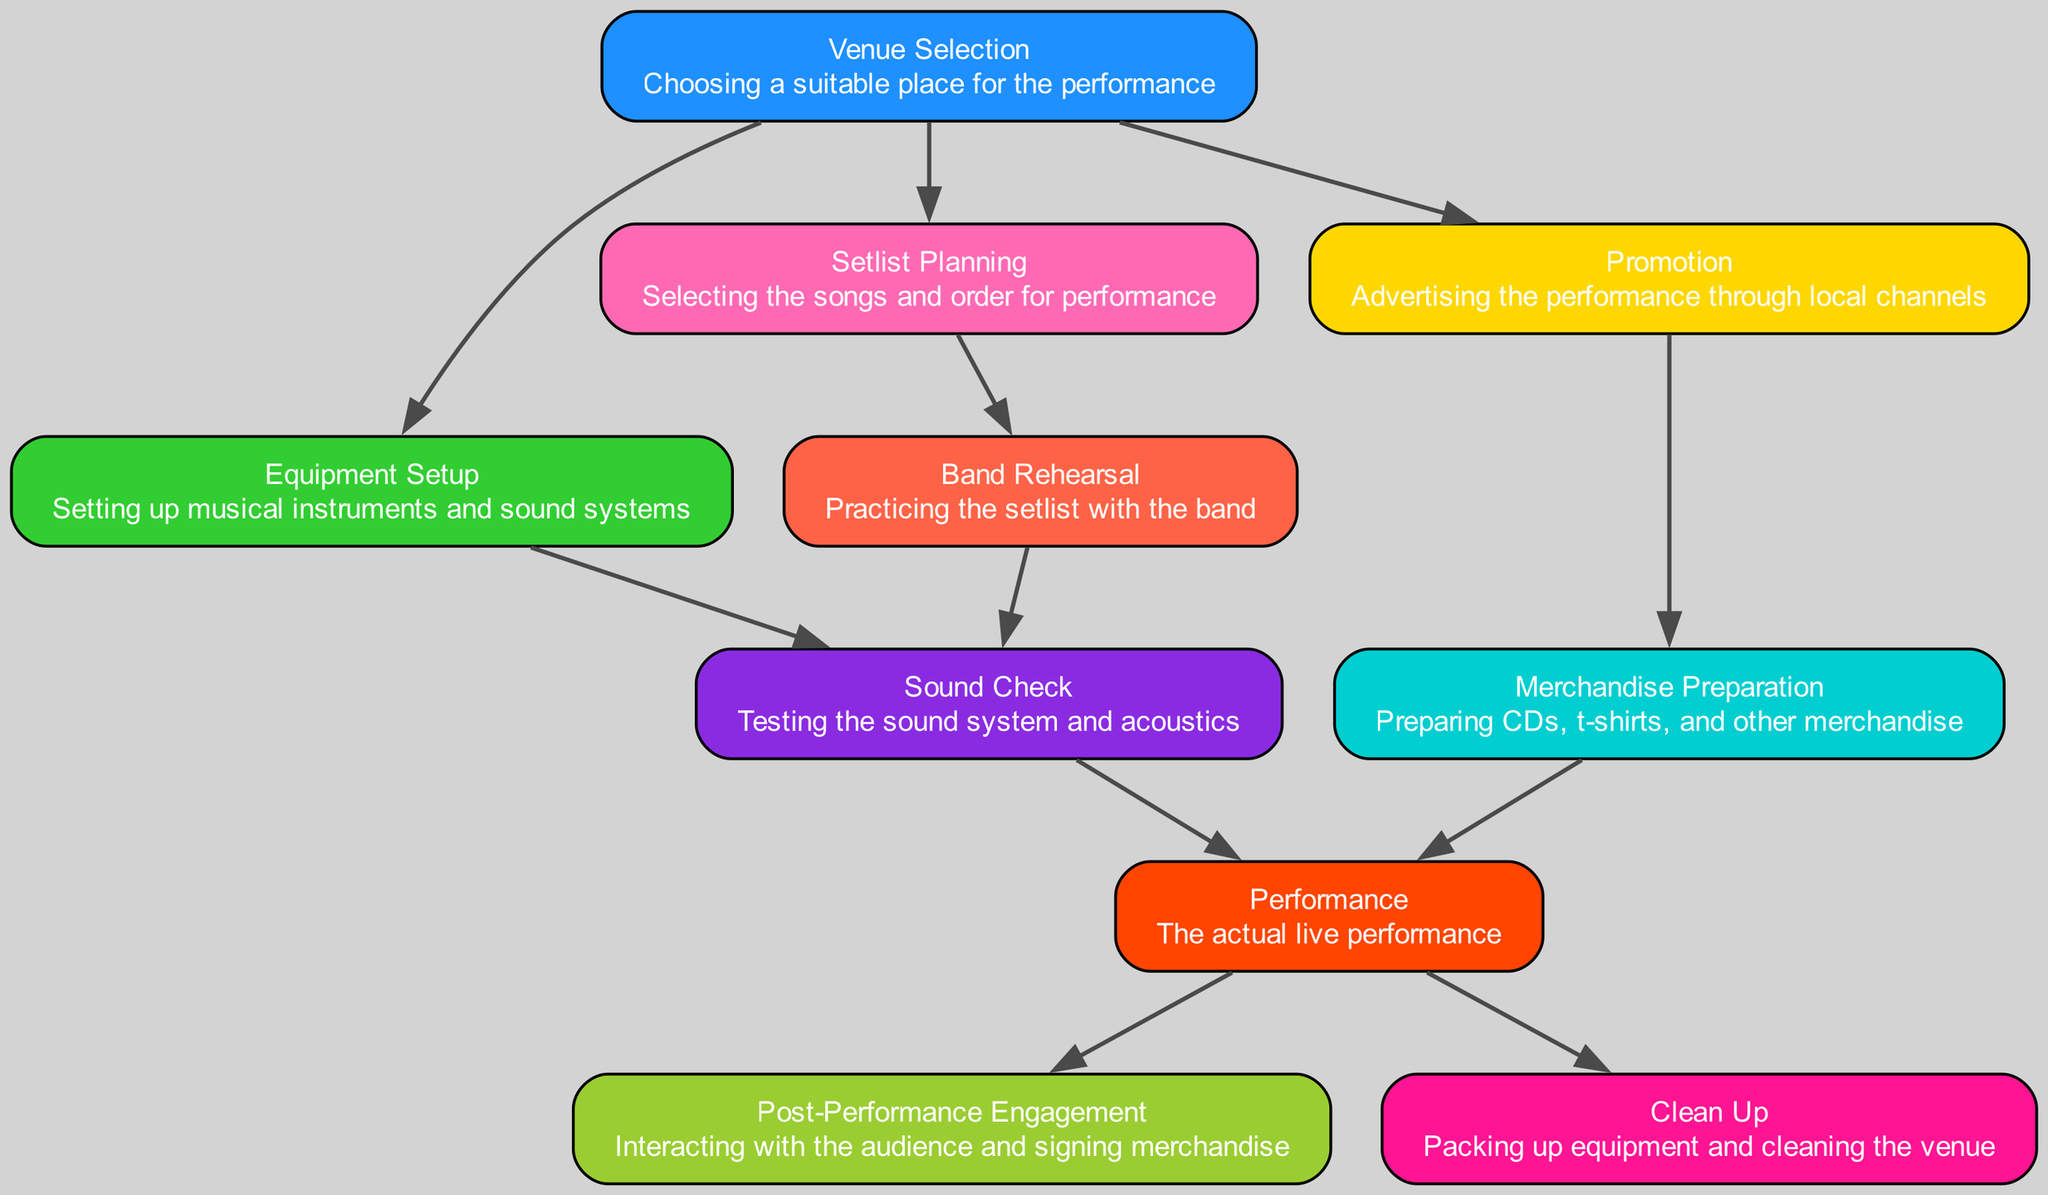What is the first step in organizing a weekend performance? The first step is 'Venue Selection,' which is depicted as the foundational element in the diagram without any dependencies. It's the starting point for any performance organization activities.
Answer: Venue Selection How many total nodes are present in the diagram? By counting the elements listed in the data, there are ten entities shown in the diagram, which represent different steps in organizing the performance.
Answer: 10 Which node directly depends on 'Setlist Planning'? 'Band Rehearsal' is the only node directly dependent on 'Setlist Planning,' which indicates that planning the setlist is necessary before rehearsing with the band.
Answer: Band Rehearsal What two processes are required before the 'Performance' can take place? Both 'Sound Check' and 'Merchandise Preparation' must be completed prior to the 'Performance,' as indicated by the dependencies shown leading to the 'Performance' node.
Answer: Sound Check, Merchandise Preparation If 'Promotion' is conducted, which task can be completed next? 'Merchandise Preparation' can be completed next after 'Promotion' because it directly depends on the successful advertising done to boost sales.
Answer: Merchandise Preparation Which element requires both 'Equipment Setup' and 'Band Rehearsal'? 'Sound Check' requires both 'Equipment Setup' and 'Band Rehearsal' to ensure the sound system works correctly and that the band is ready for the performance, as shown by the flow in the diagram.
Answer: Sound Check What is the final activity listed in the performance organization process? The final activity is 'Clean Up,' which follows after the 'Performance' event, indicating it's the last task in the organizational flow shown in the diagram.
Answer: Clean Up Which element has only one dependency? 'Promotion' has only one dependency, which is 'Venue Selection,' meaning it can only occur after the venue has been ordered.
Answer: Venue Selection What is the relationship between 'Merchandise Preparation' and 'Promotion'? 'Merchandise Preparation' is dependent on 'Promotion,' indicating that it should happen after advertising efforts are made for the performance.
Answer: Dependent 